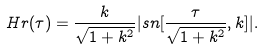Convert formula to latex. <formula><loc_0><loc_0><loc_500><loc_500>H r ( \tau ) = \frac { k } { \sqrt { 1 + k ^ { 2 } } } | s n [ \frac { \tau } { \sqrt { 1 + k ^ { 2 } } } , k ] | .</formula> 